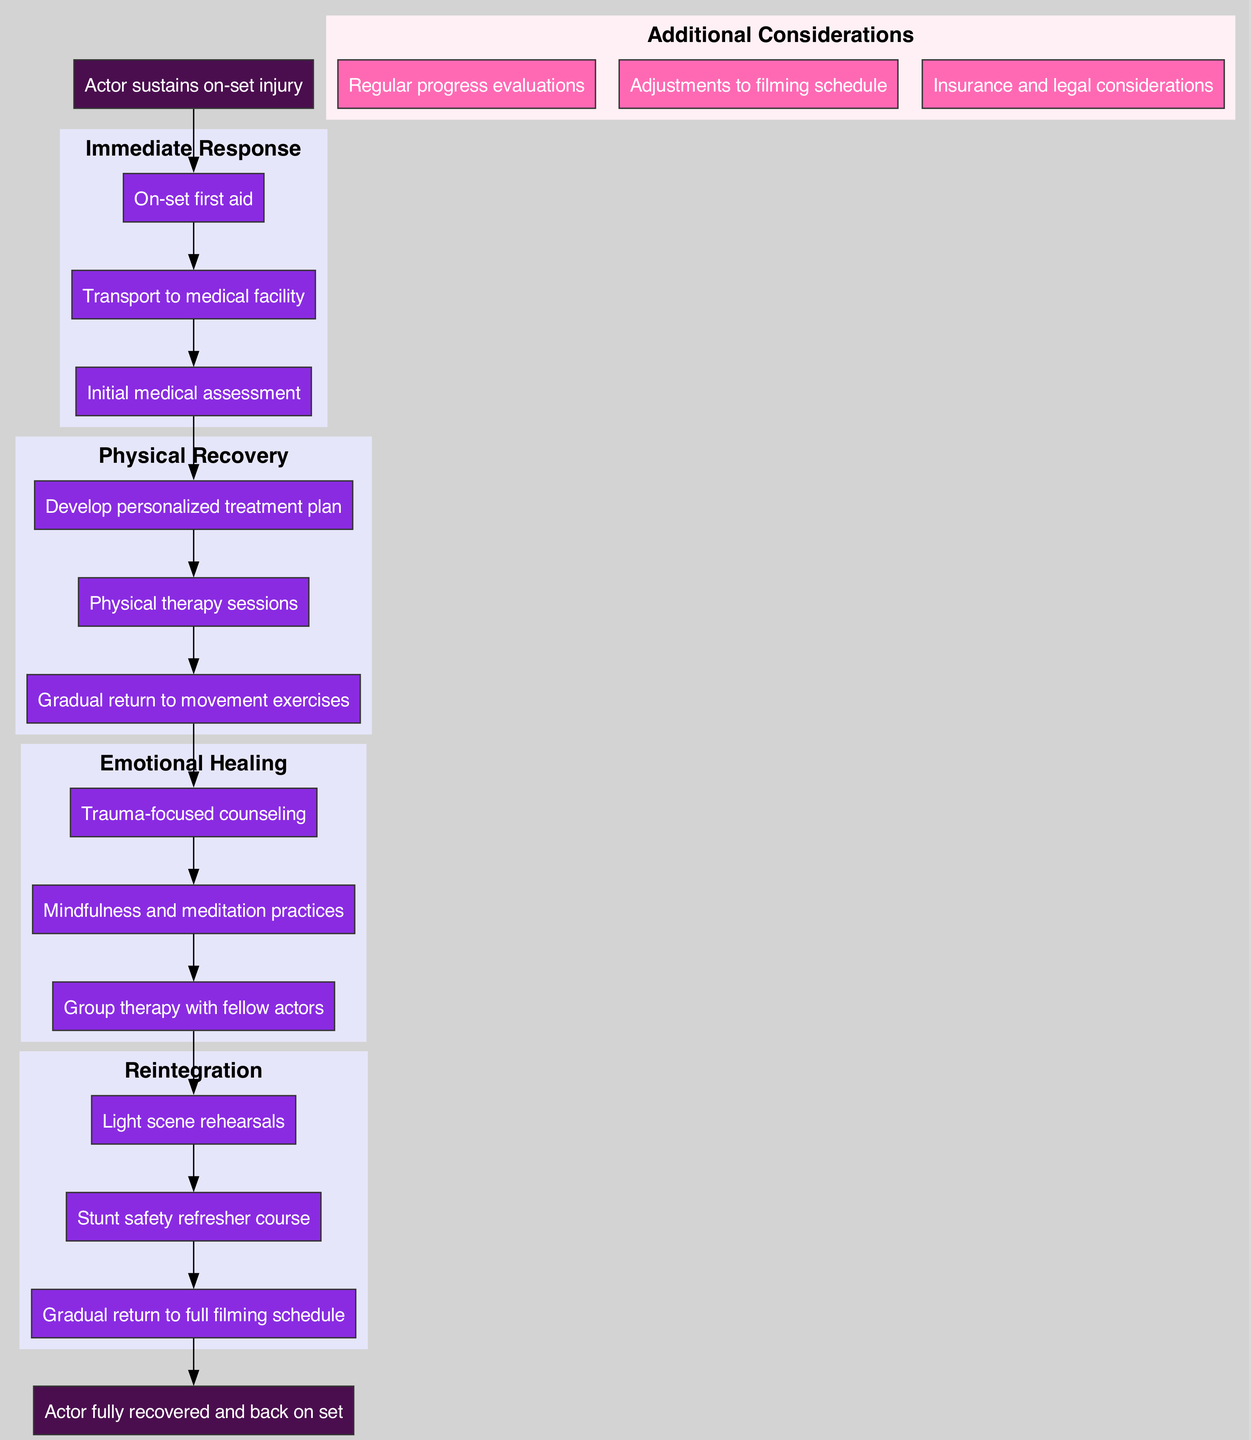What is the first step an actor takes after sustaining an on-set injury? According to the diagram, the first step is "On-set first aid." This is listed as the very first action taken following the injury.
Answer: On-set first aid How many phases are there in the rehabilitation protocol? The diagram shows four distinct phases: Immediate Response, Physical Recovery, Emotional Healing, and Reintegration. This total counts all phases mentioned.
Answer: 4 What step comes after "Gradual return to movement exercises"? "Trauma-focused counseling" follows in the Emotional Healing phase. This step is linked to the Physical Recovery phase.
Answer: Trauma-focused counseling Which phase includes therapy with fellow actors? The Emotional Healing phase focuses primarily on emotional recovery, which includes group therapy with fellow actors as a step in this phase.
Answer: Emotional Healing What is the last step before the actor returns to the set? The final step before the actor is back on set is "Gradual return to full filming schedule." This step culminates the rehabilitation process.
Answer: Gradual return to full filming schedule How many steps are included in the Physical Recovery phase? The Physical Recovery phase consists of three steps: Develop personalized treatment plan, Physical therapy sessions, and Gradual return to movement exercises. This is counted directly from the phase.
Answer: 3 What additional consideration might affect the filming schedule? The diagram lists "Adjustments to filming schedule" as an additional consideration, indicating that it may impact how filming is organized following rehabilitation.
Answer: Adjustments to filming schedule What step directly follows "Transport to medical facility"? The next step after "Transport to medical facility" is "Initial medical assessment." This step is sequentially arranged in the Immediate Response phase.
Answer: Initial medical assessment Which step links the Immediate Response to the Physical Recovery phase? The step "Gradual return to movement exercises" in the Physical Recovery phase is linked through sequential transitions from the last step of Immediate Response.
Answer: Gradual return to movement exercises 